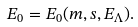Convert formula to latex. <formula><loc_0><loc_0><loc_500><loc_500>E _ { 0 } = E _ { 0 } ( m , s , E _ { \Lambda } ) .</formula> 